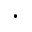<formula> <loc_0><loc_0><loc_500><loc_500>\cdot</formula> 